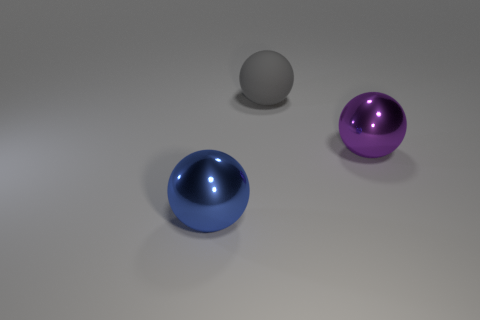There is a large gray matte thing; is its shape the same as the big metallic object that is behind the blue metallic object?
Your response must be concise. Yes. What number of objects are either large gray metal cubes or shiny things?
Make the answer very short. 2. What shape is the object on the left side of the big thing behind the large purple ball?
Offer a terse response. Sphere. There is a blue object that is in front of the big matte thing; is its shape the same as the large purple thing?
Your answer should be compact. Yes. There is a blue thing that is made of the same material as the big purple object; what size is it?
Provide a succinct answer. Large. How many things are large objects that are behind the big purple ball or purple shiny balls to the right of the large blue shiny thing?
Your response must be concise. 2. Are there an equal number of gray rubber balls that are left of the blue shiny thing and purple balls that are to the right of the large purple shiny sphere?
Keep it short and to the point. Yes. The big shiny ball that is to the right of the blue metallic sphere is what color?
Provide a short and direct response. Purple. There is a large rubber ball; does it have the same color as the ball that is in front of the large purple metallic sphere?
Your response must be concise. No. Is the number of purple spheres less than the number of metal things?
Give a very brief answer. Yes. 